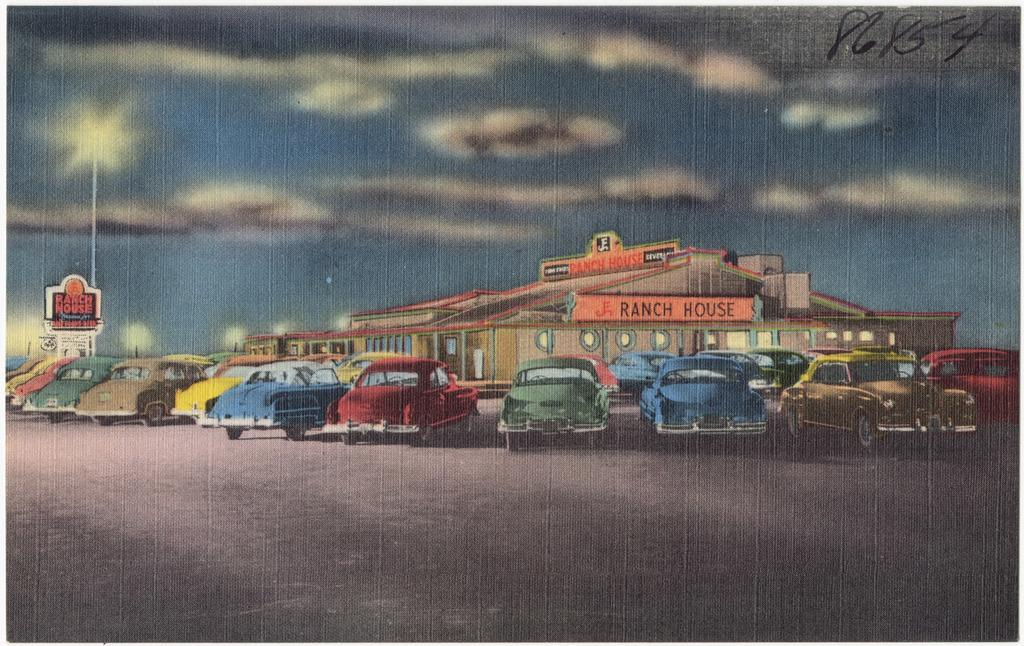What type of vehicles are depicted in the image? There is a depiction of cars in the image. What type of building is depicted in the image? There is a depiction of a house in the image. What type of street fixture is depicted in the image? There is a depiction of a street light in the image. What part of the natural environment is depicted in the image? There is a depiction of the sky and clouds in the image. How many cows are depicted in the image? There are no cows depicted in the image. What type of watch is being worn by the car in the image? There are no watches depicted in the image, as it features cars, a house, a street light, the sky, and clouds. 